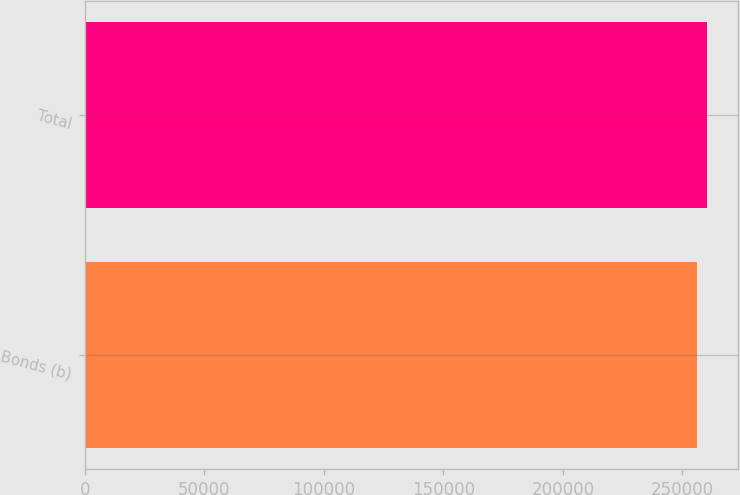Convert chart. <chart><loc_0><loc_0><loc_500><loc_500><bar_chart><fcel>Bonds (b)<fcel>Total<nl><fcel>255946<fcel>260379<nl></chart> 